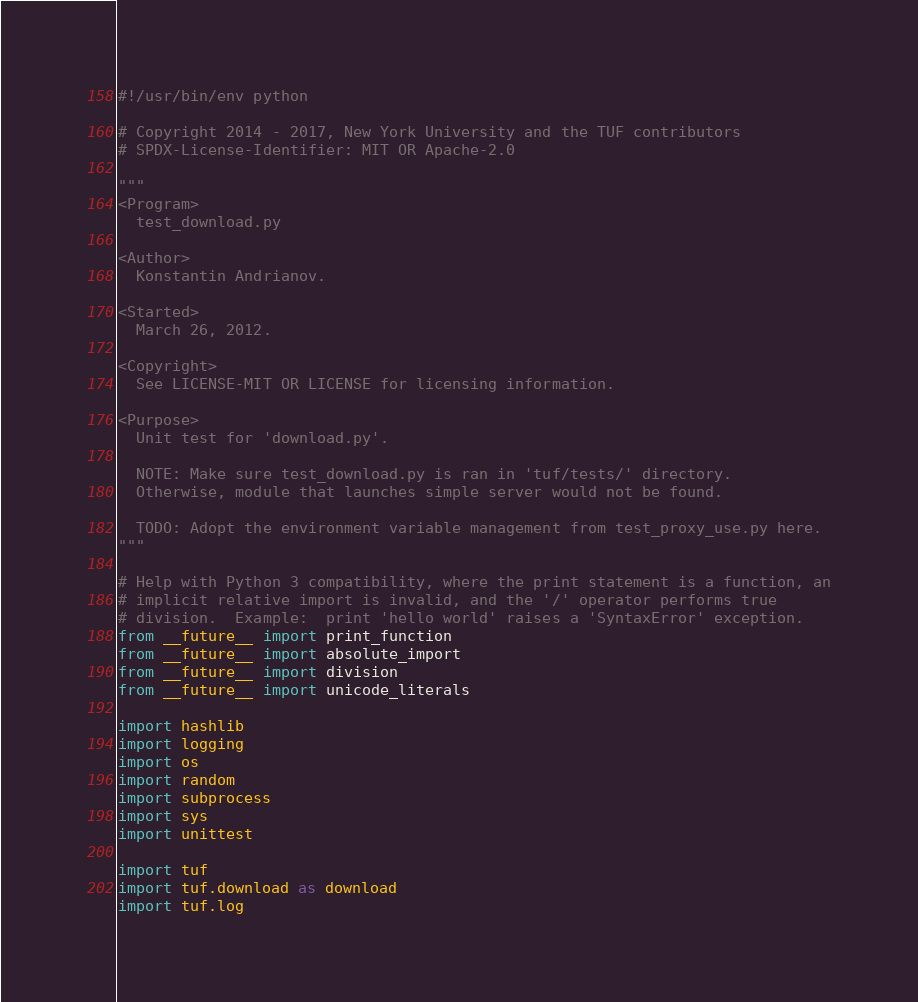Convert code to text. <code><loc_0><loc_0><loc_500><loc_500><_Python_>#!/usr/bin/env python

# Copyright 2014 - 2017, New York University and the TUF contributors
# SPDX-License-Identifier: MIT OR Apache-2.0

"""
<Program>
  test_download.py

<Author>
  Konstantin Andrianov.

<Started>
  March 26, 2012.

<Copyright>
  See LICENSE-MIT OR LICENSE for licensing information.

<Purpose>
  Unit test for 'download.py'.

  NOTE: Make sure test_download.py is ran in 'tuf/tests/' directory.
  Otherwise, module that launches simple server would not be found.

  TODO: Adopt the environment variable management from test_proxy_use.py here.
"""

# Help with Python 3 compatibility, where the print statement is a function, an
# implicit relative import is invalid, and the '/' operator performs true
# division.  Example:  print 'hello world' raises a 'SyntaxError' exception.
from __future__ import print_function
from __future__ import absolute_import
from __future__ import division
from __future__ import unicode_literals

import hashlib
import logging
import os
import random
import subprocess
import sys
import unittest

import tuf
import tuf.download as download
import tuf.log</code> 